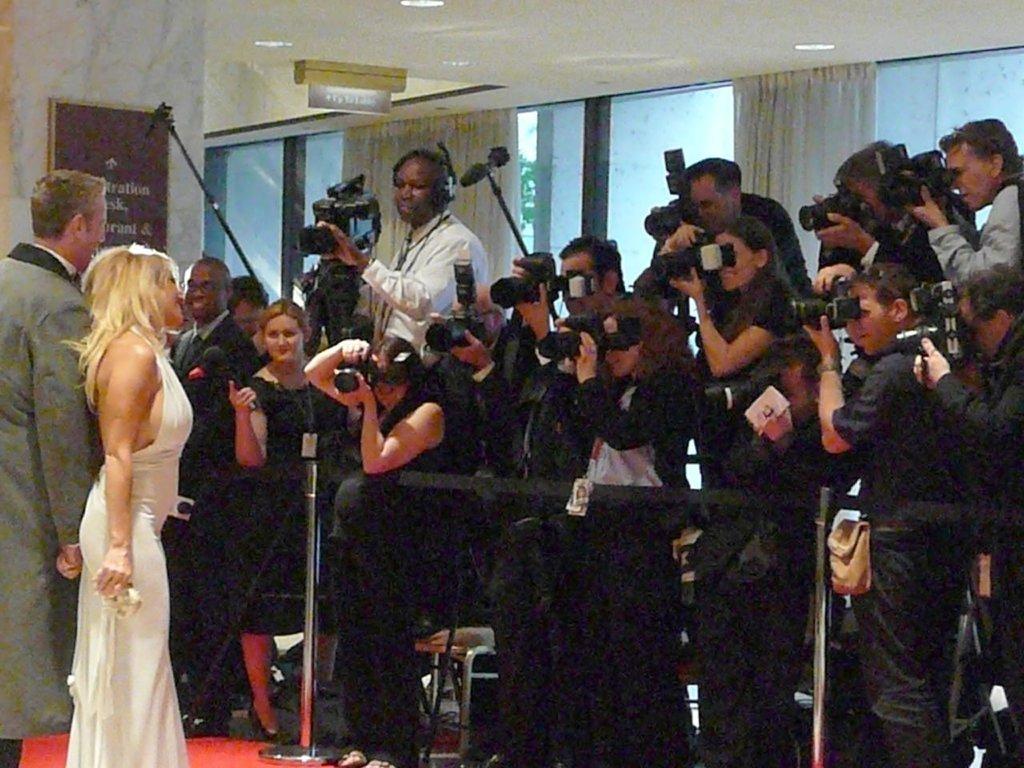Can you describe this image briefly? In the picture we can see a man and a woman standing, and many people are capturing them with cameras and in the background, we can see a wall with a glass window and a curtain. 